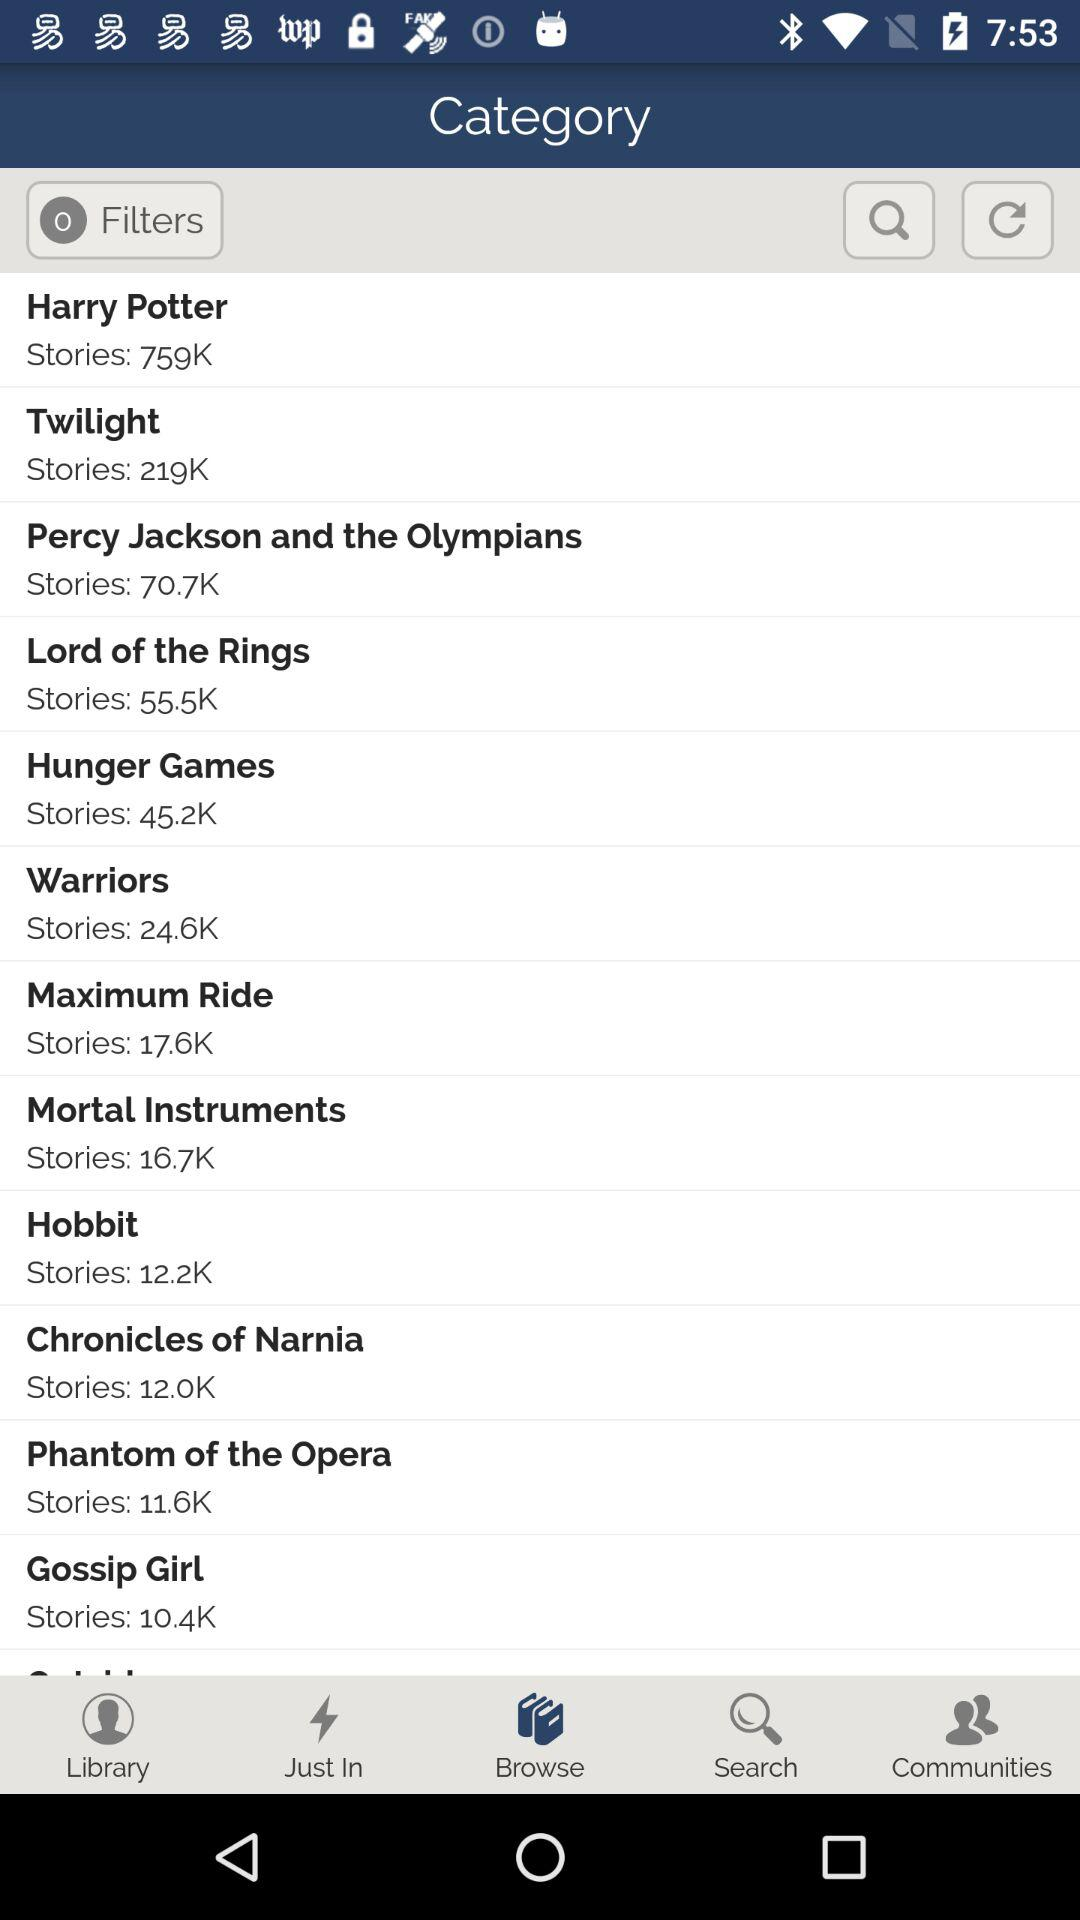How many notifications are there in "Library"?
When the provided information is insufficient, respond with <no answer>. <no answer> 